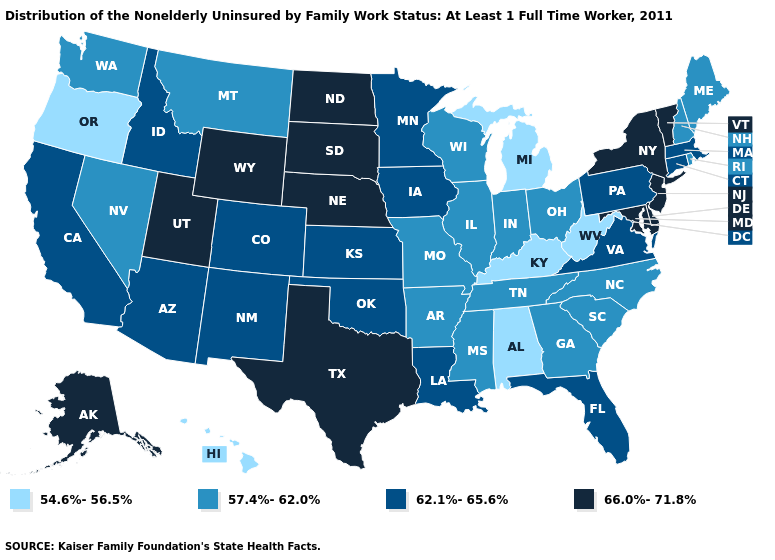What is the value of Maryland?
Write a very short answer. 66.0%-71.8%. Name the states that have a value in the range 54.6%-56.5%?
Concise answer only. Alabama, Hawaii, Kentucky, Michigan, Oregon, West Virginia. Is the legend a continuous bar?
Short answer required. No. Name the states that have a value in the range 57.4%-62.0%?
Keep it brief. Arkansas, Georgia, Illinois, Indiana, Maine, Mississippi, Missouri, Montana, Nevada, New Hampshire, North Carolina, Ohio, Rhode Island, South Carolina, Tennessee, Washington, Wisconsin. Which states have the highest value in the USA?
Concise answer only. Alaska, Delaware, Maryland, Nebraska, New Jersey, New York, North Dakota, South Dakota, Texas, Utah, Vermont, Wyoming. Does Iowa have a lower value than Mississippi?
Concise answer only. No. What is the value of Hawaii?
Quick response, please. 54.6%-56.5%. How many symbols are there in the legend?
Be succinct. 4. Does West Virginia have the lowest value in the USA?
Concise answer only. Yes. What is the value of Minnesota?
Quick response, please. 62.1%-65.6%. What is the value of Georgia?
Quick response, please. 57.4%-62.0%. What is the value of North Carolina?
Concise answer only. 57.4%-62.0%. Does the map have missing data?
Concise answer only. No. Name the states that have a value in the range 66.0%-71.8%?
Answer briefly. Alaska, Delaware, Maryland, Nebraska, New Jersey, New York, North Dakota, South Dakota, Texas, Utah, Vermont, Wyoming. Name the states that have a value in the range 54.6%-56.5%?
Write a very short answer. Alabama, Hawaii, Kentucky, Michigan, Oregon, West Virginia. 